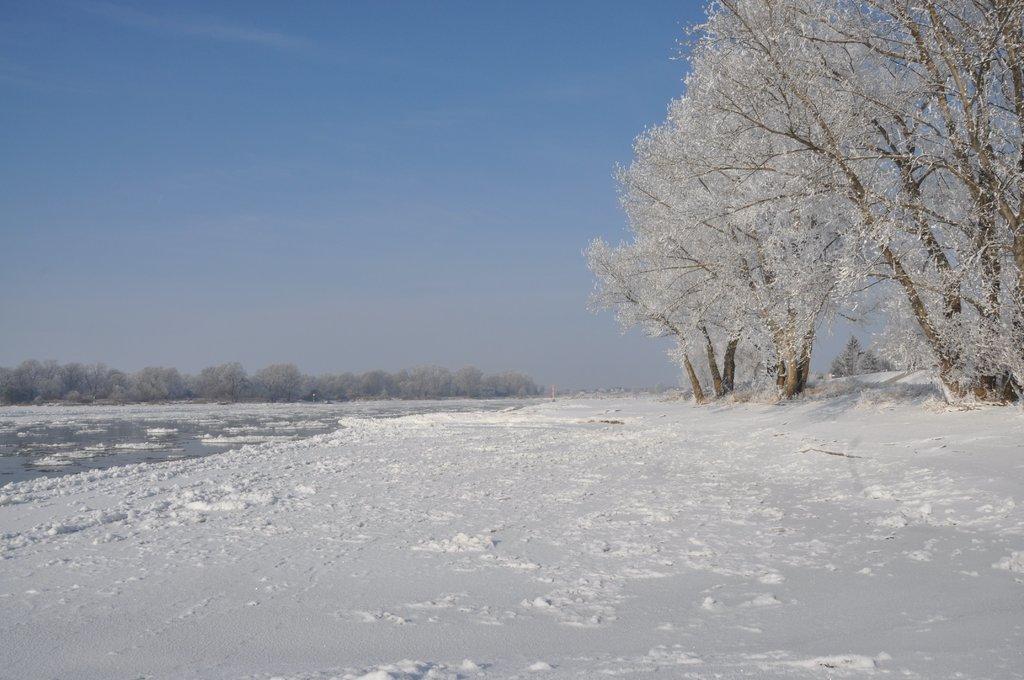In one or two sentences, can you explain what this image depicts? In this image, we can see so many trees. At the bottom, there is a snow. Background we can see water. Top of the image, there is a sky. 